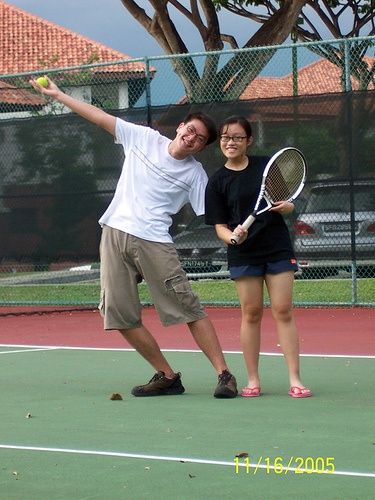Describe the objects in this image and their specific colors. I can see people in lightpink, lavender, gray, and black tones, people in lightpink, black, brown, and tan tones, car in lightpink, black, gray, darkgray, and purple tones, car in lightpink, black, gray, purple, and darkgray tones, and tennis racket in lightpink, gray, black, white, and darkgreen tones in this image. 